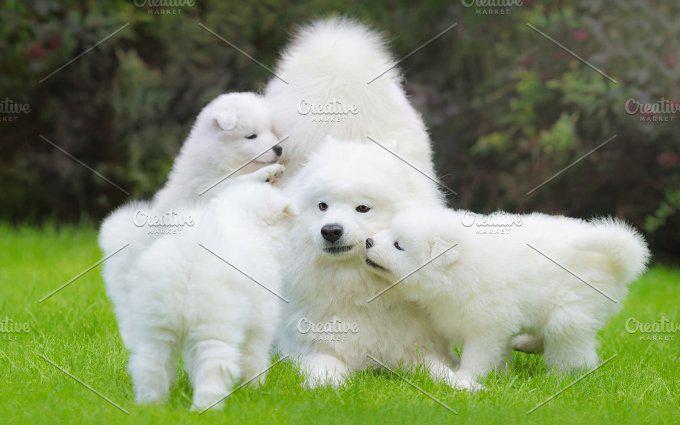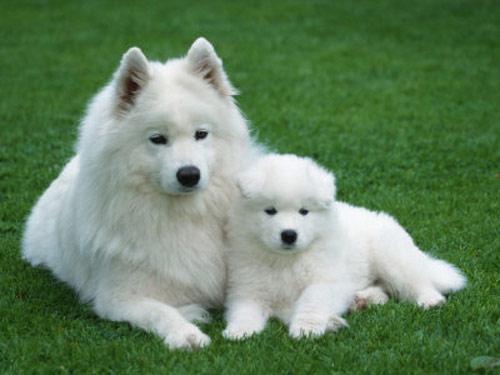The first image is the image on the left, the second image is the image on the right. Examine the images to the left and right. Is the description "There are no more than three dogs" accurate? Answer yes or no. No. 